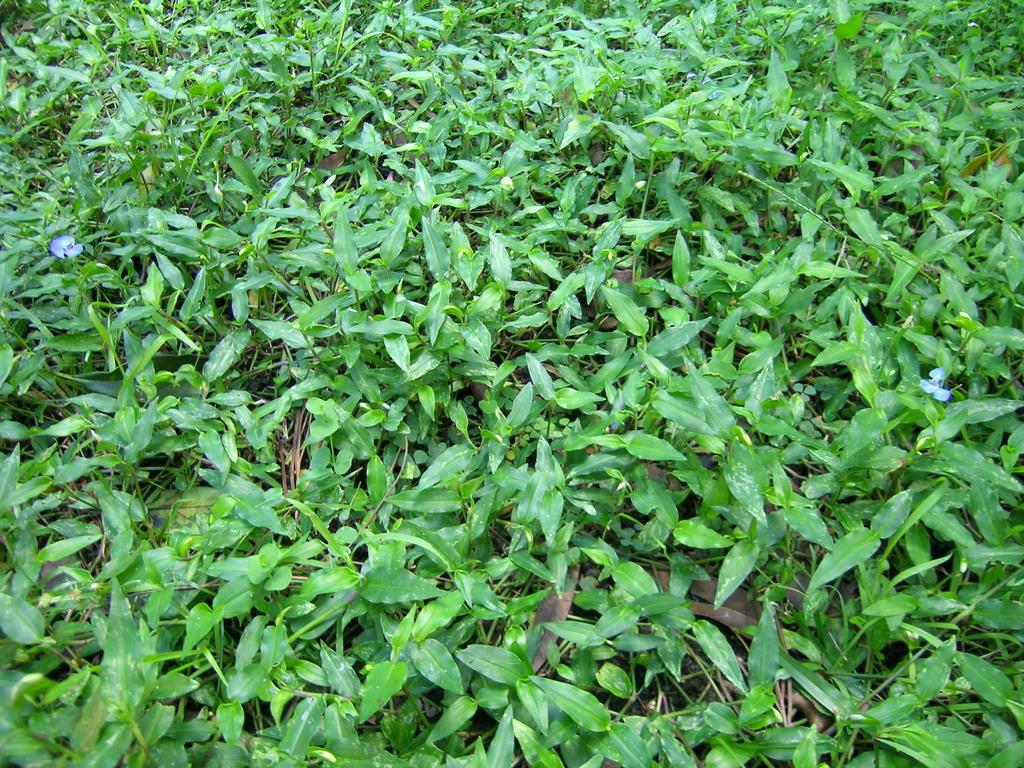What type of objects are present in the image? There are many plants in the image. Can you describe any specific features of the plants? Yes, there are purple color flowers in the image. Reasoning: Let' Let's think step by step in order to produce the conversation. We start by identifying the main subject of the image, which is the plants. Then, we describe specific features of the plants, such as the purple color flowers. We avoid yes/no questions and ensure that the language is simple and clear. Absurd Question/Answer: What type of ray can be seen swimming in the image? There is no ray present in the image; it features many plants with purple color flowers. What kind of stone is being used to build the structure in the image? There is no structure or stone present in the image; it only contains plants and flowers. What type of shock can be seen affecting the plants in the image? There is no shock present in the image; it features many plants with purple color flowers. What kind of creature is causing the shock to the plants in the image? There is no creature or shock present in the image; it only contains plants and flowers. 